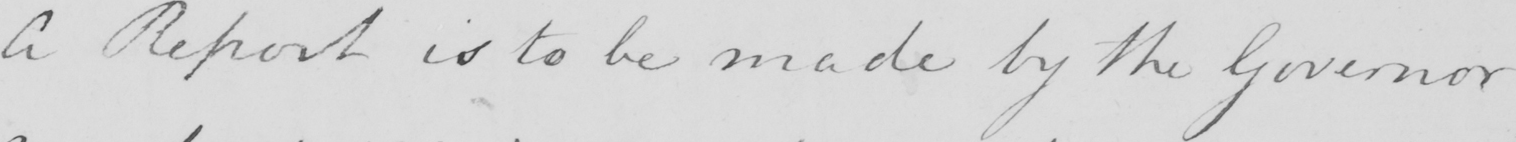What is written in this line of handwriting? A Report is to be made by the Governor 